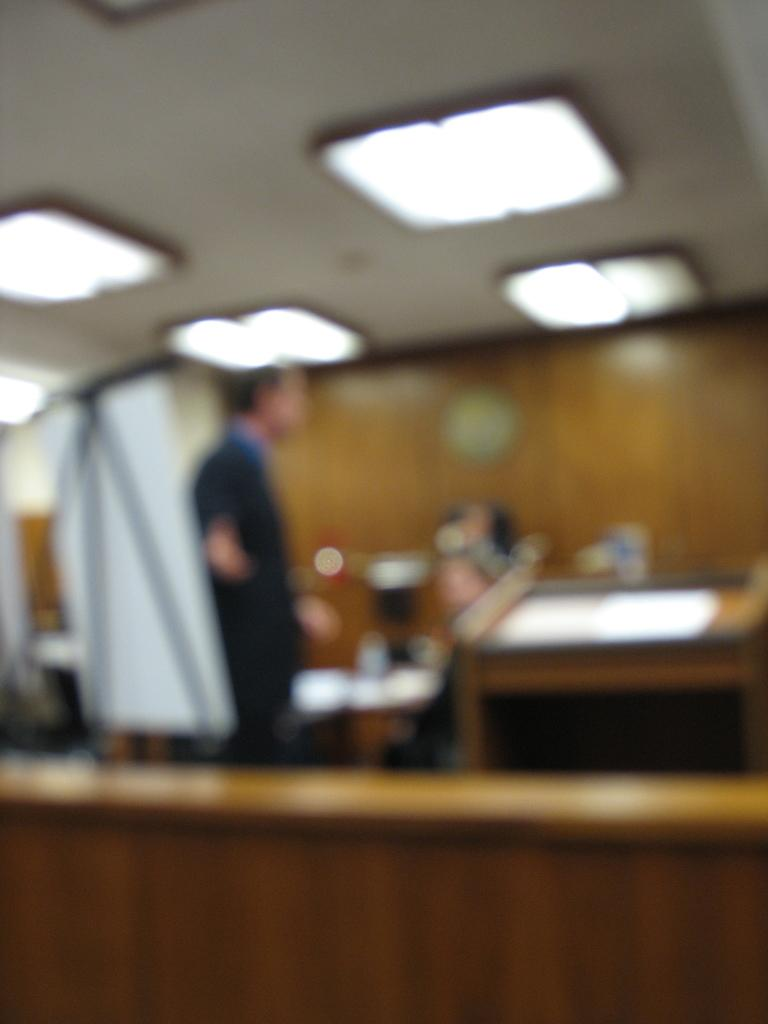What is the main subject in the image? There is a person standing in the image. What type of material can be seen in the image? There is cloth visible in the image. What type of structure is present in the image? There is a wall in the image. What can be used for illumination in the image? There are lights in the image. What type of food is being prepared by the person in the image? There is no food preparation visible in the image; the person is simply standing. 